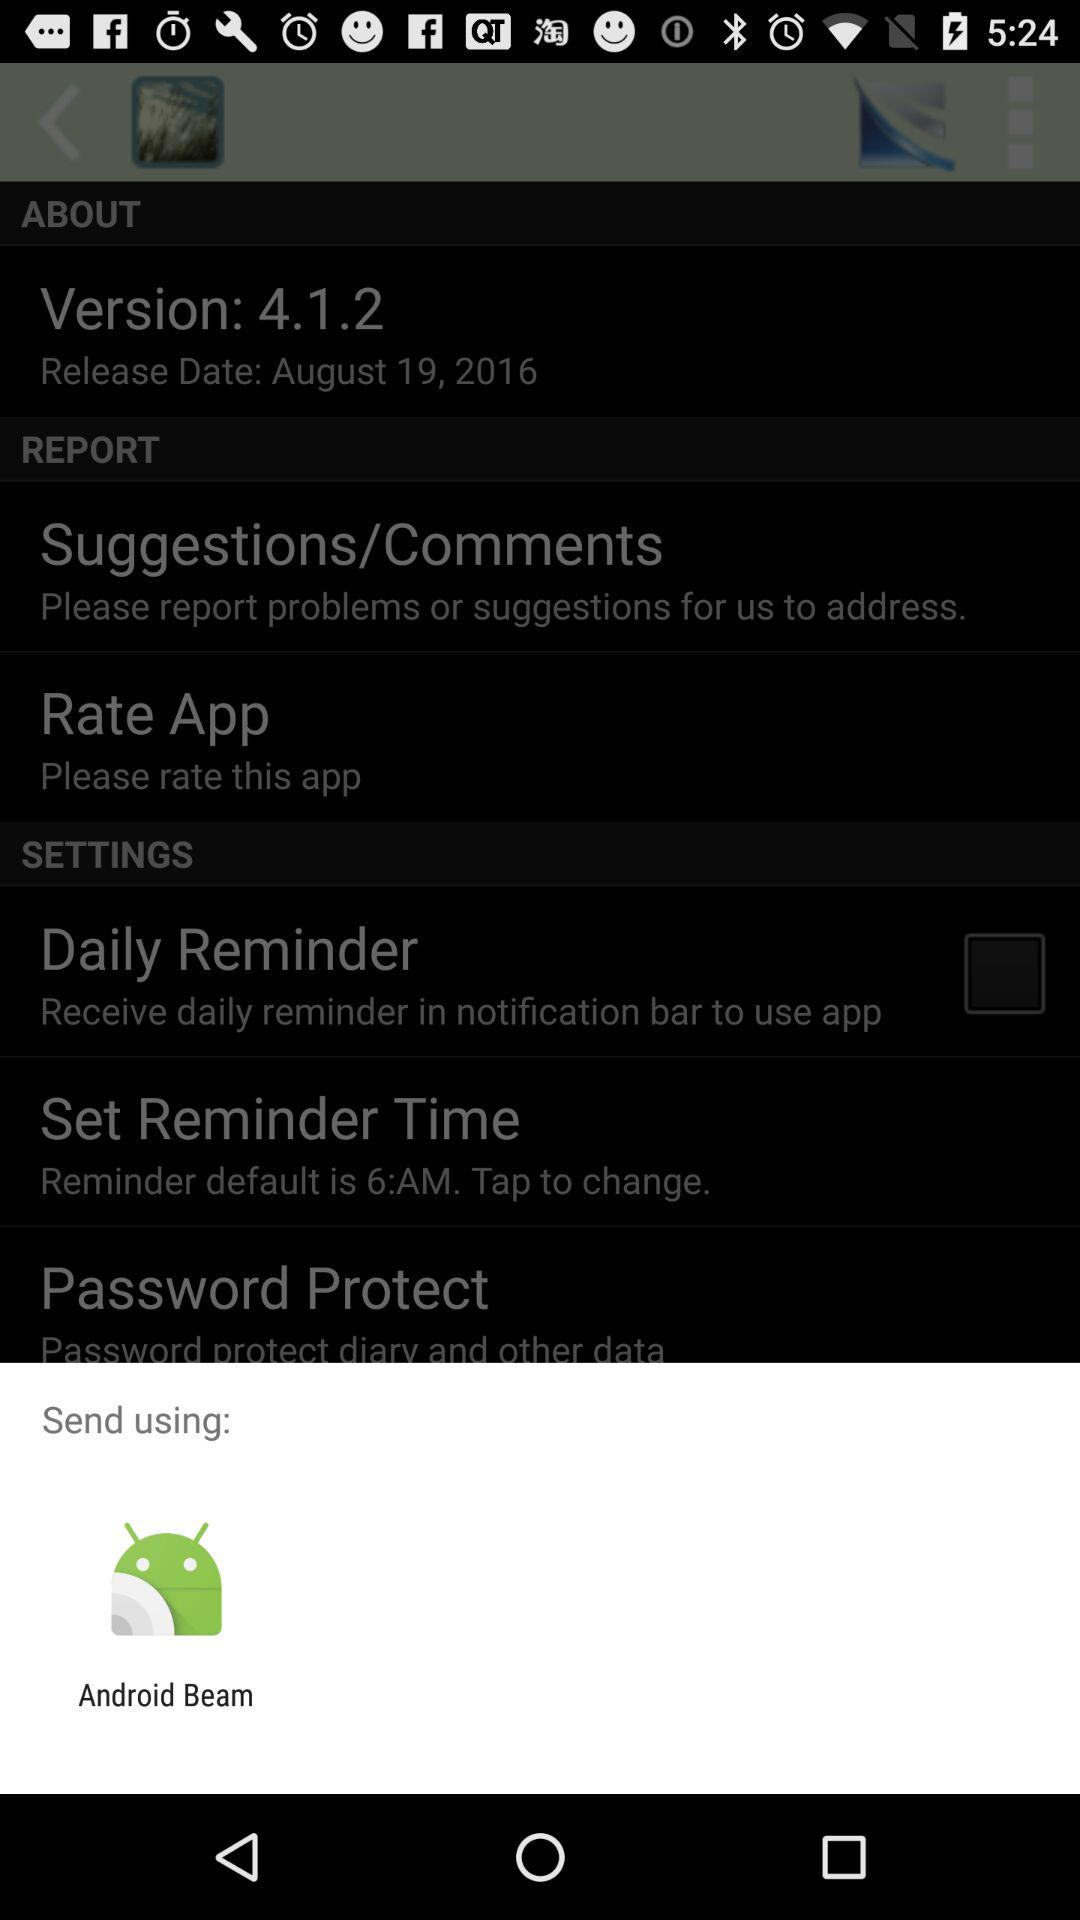What is the release date? The release date is August 19, 2016. 